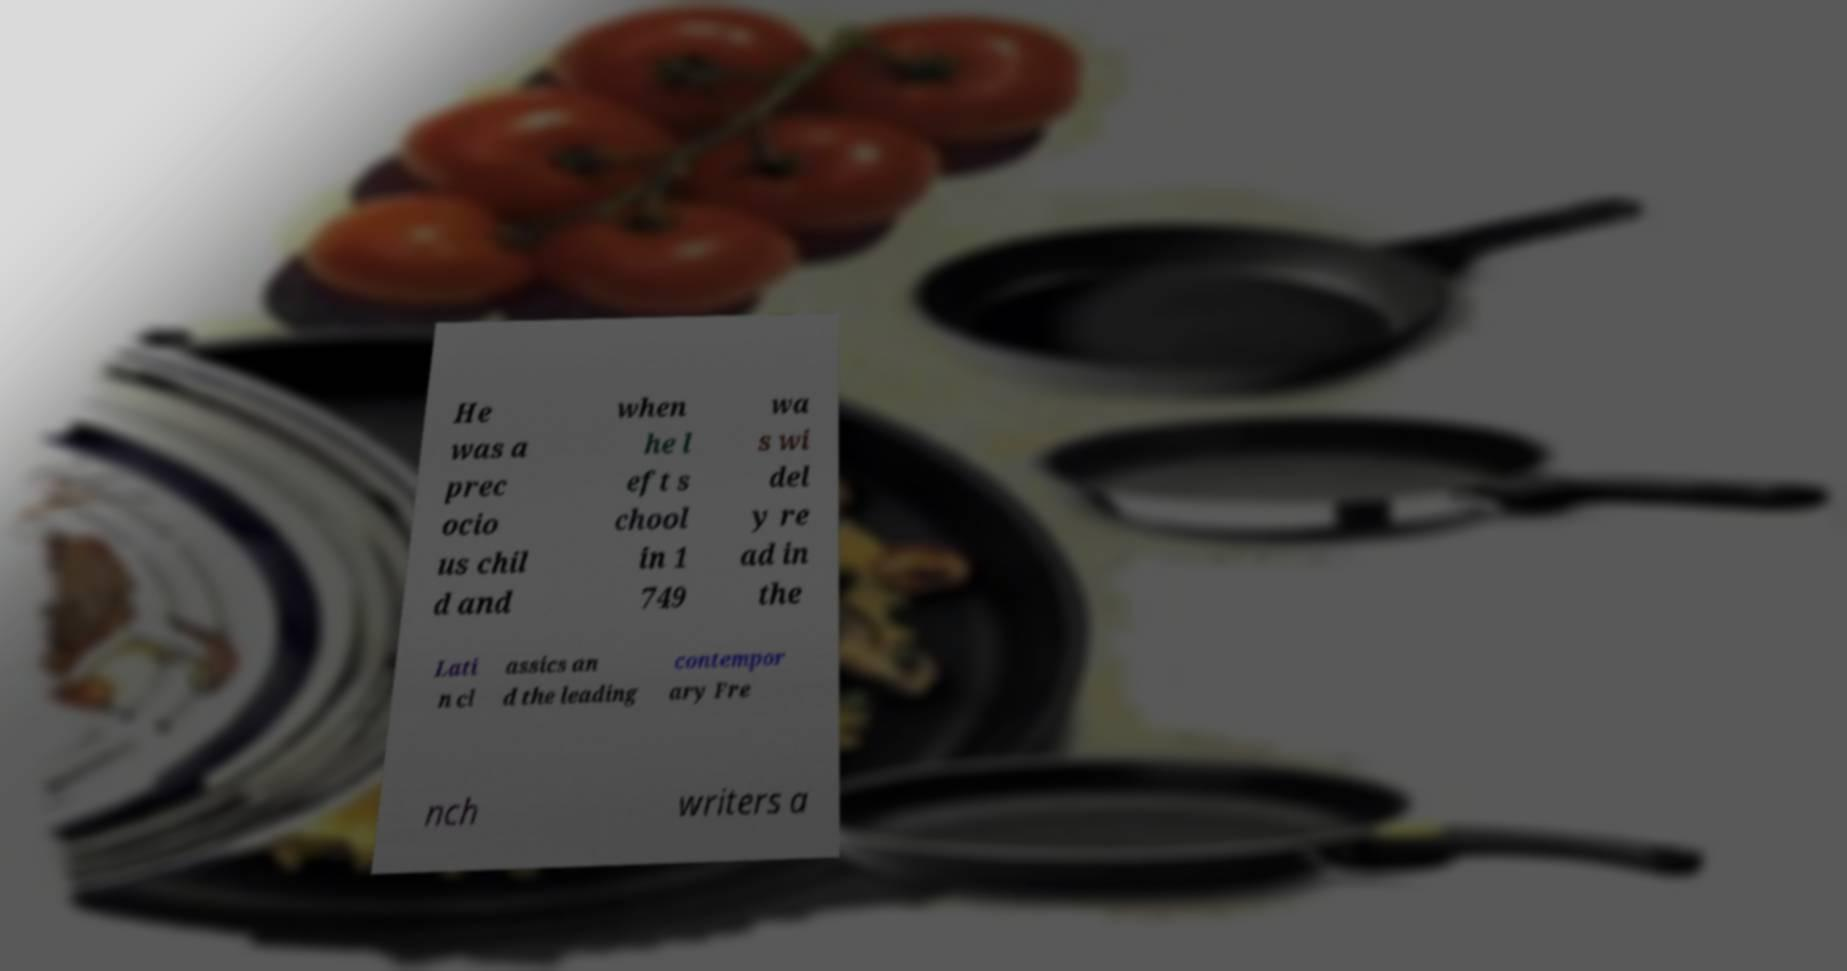For documentation purposes, I need the text within this image transcribed. Could you provide that? He was a prec ocio us chil d and when he l eft s chool in 1 749 wa s wi del y re ad in the Lati n cl assics an d the leading contempor ary Fre nch writers a 